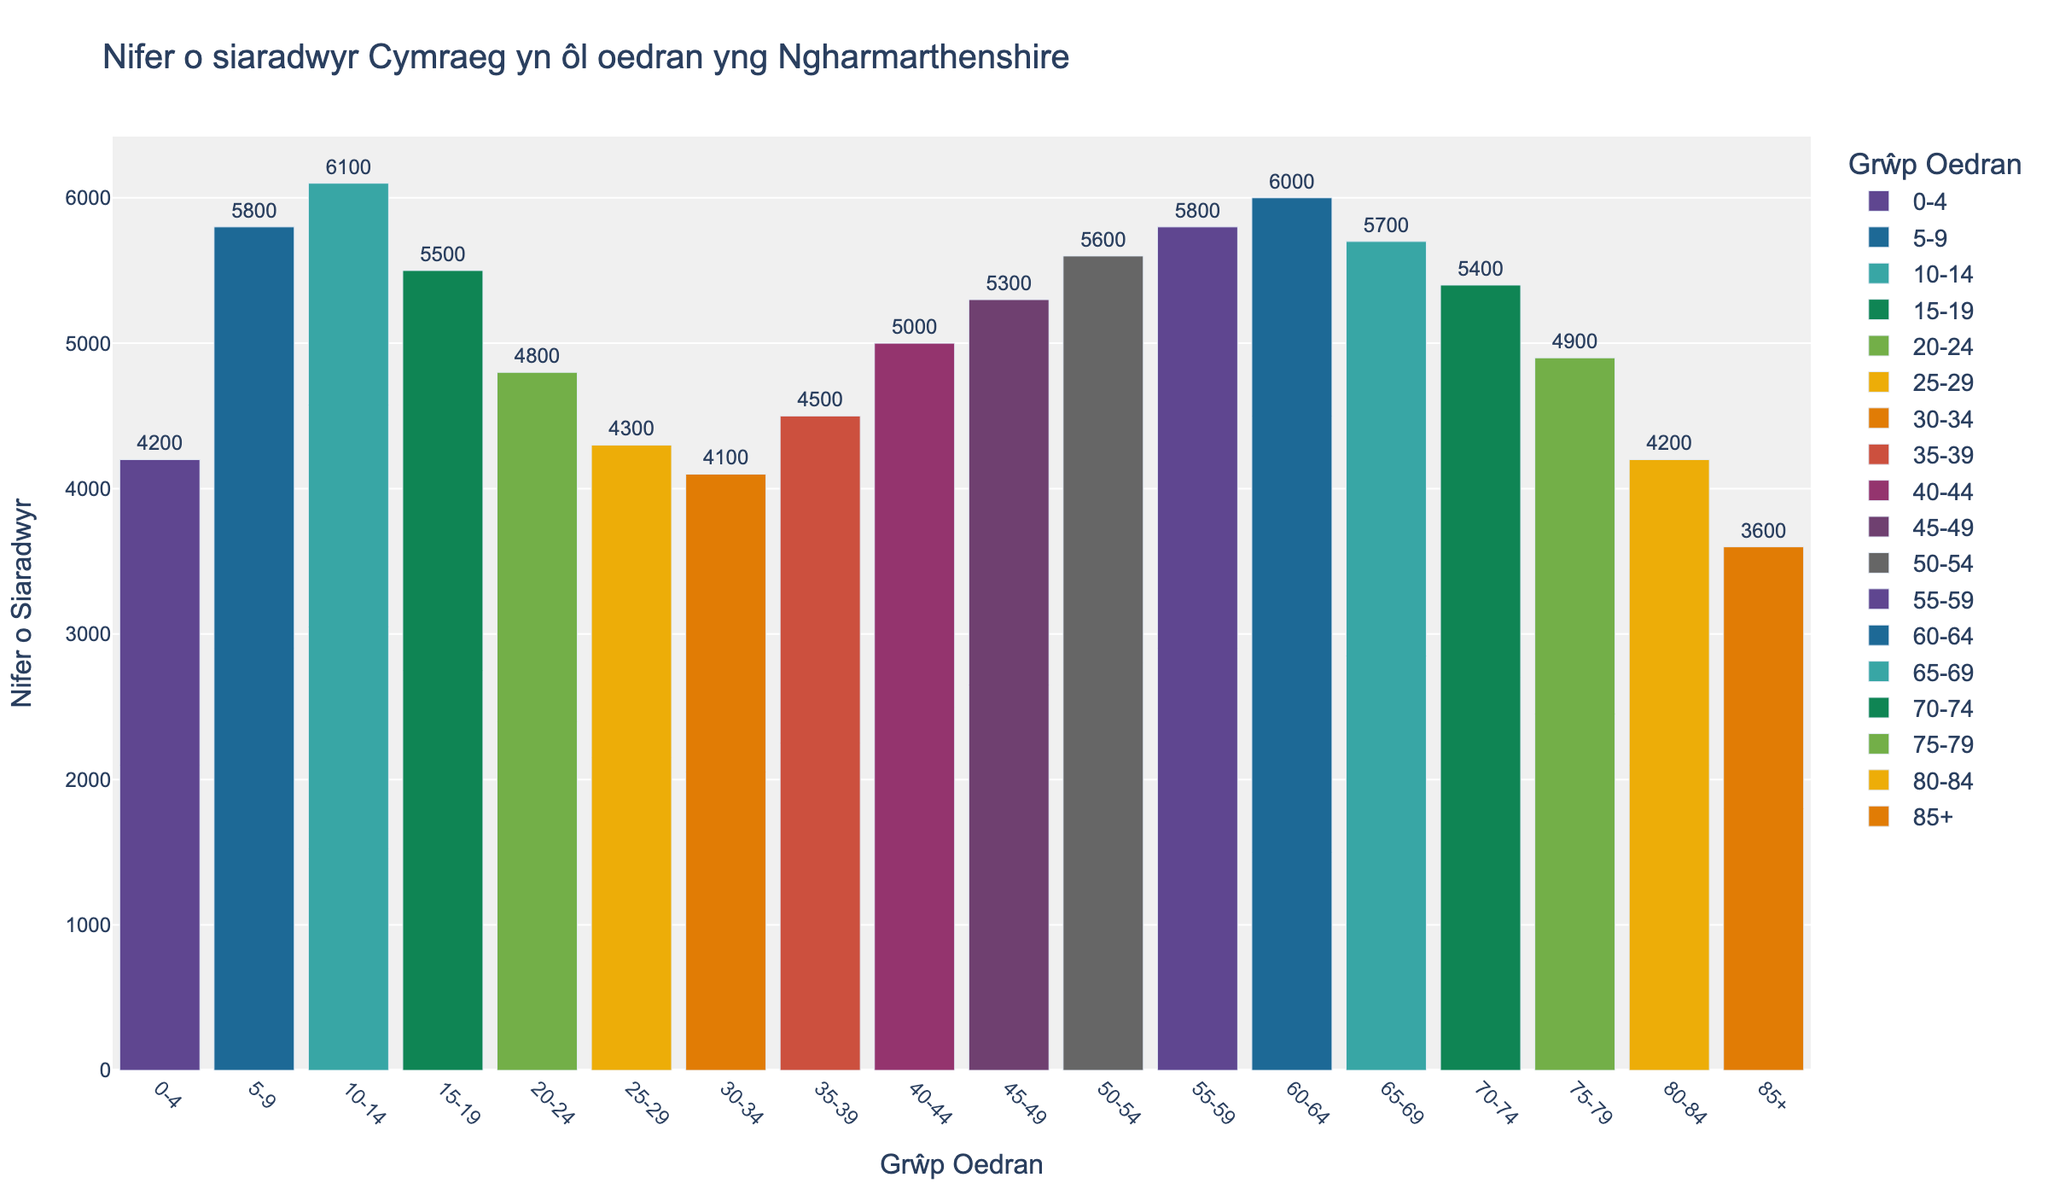Pa grŵp oedran sydd â'r nifer uchaf o siaradwyr Cymraeg? edrychwch ar y bar mwyaf yn y graff i ganfod y grŵp oedran
Answer: 10-14 Pa grŵp oedran sydd â'r nifer isaf o siaradwyr Cymraeg? edrychwch ar y bar lleiaf yn y graff i ganfod y grŵp oedran
Answer: 85+ Pa grŵp oedran sydd gan y nifer o siaradwyr Cymraeg tua 4800? edrychwch ar y bar gan chwilio am y gwerth 4800 a dangos y grŵp oedran yn cyfateb
Answer: 20-24 Pa grŵp oedran sydd â nifer siaradwyr Cymraeg yn cyfateb i 5700? edrychwch ar y bar gan chwilio am y gwerth 5700 a dangos y grŵp oedran yn cyfateb
Answer: 65-69 Beth yw'r grŵp oedran nesaf lle mae'r nifer o siaradwyr Cymraeg yn is na 4000? edrychwch ar y bar a ddangos y gwerth yn is na 4000
Answer: 85+ 